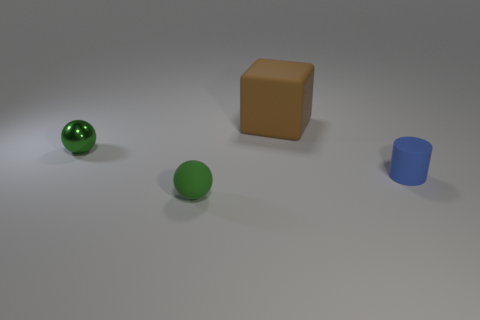Is the color of the rubber thing that is on the left side of the big block the same as the shiny thing?
Offer a very short reply. Yes. How big is the matte thing that is on the left side of the brown cube behind the tiny blue rubber thing?
Provide a succinct answer. Small. Are there more small green balls that are right of the metal sphere than tiny cyan metal things?
Your response must be concise. Yes. Is the size of the sphere that is to the left of the green matte sphere the same as the matte cube?
Give a very brief answer. No. What is the color of the object that is both in front of the big brown object and behind the tiny blue matte cylinder?
Provide a short and direct response. Green. What shape is the blue object that is the same size as the green rubber object?
Your answer should be very brief. Cylinder. Is there another sphere of the same color as the shiny sphere?
Offer a terse response. Yes. Is the number of large brown objects to the right of the tiny cylinder the same as the number of purple matte cubes?
Your answer should be compact. Yes. Does the small shiny sphere have the same color as the rubber ball?
Provide a succinct answer. Yes. What is the size of the matte object that is to the left of the small matte cylinder and behind the matte sphere?
Keep it short and to the point. Large. 